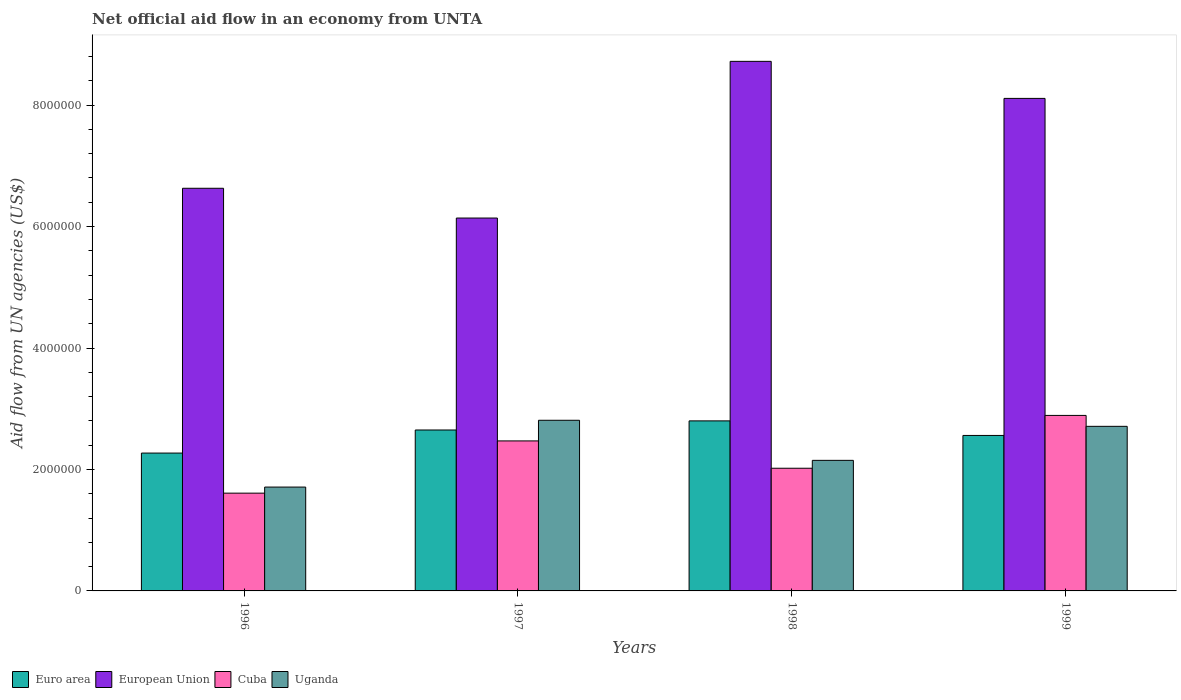How many groups of bars are there?
Make the answer very short. 4. Are the number of bars per tick equal to the number of legend labels?
Make the answer very short. Yes. How many bars are there on the 2nd tick from the left?
Your answer should be compact. 4. How many bars are there on the 2nd tick from the right?
Make the answer very short. 4. What is the net official aid flow in Euro area in 1996?
Ensure brevity in your answer.  2.27e+06. Across all years, what is the maximum net official aid flow in Cuba?
Your answer should be very brief. 2.89e+06. Across all years, what is the minimum net official aid flow in Cuba?
Offer a terse response. 1.61e+06. What is the total net official aid flow in Uganda in the graph?
Your answer should be compact. 9.38e+06. What is the difference between the net official aid flow in European Union in 1997 and that in 1998?
Your answer should be very brief. -2.58e+06. What is the difference between the net official aid flow in Cuba in 1998 and the net official aid flow in European Union in 1996?
Keep it short and to the point. -4.61e+06. What is the average net official aid flow in Uganda per year?
Keep it short and to the point. 2.34e+06. In the year 1996, what is the difference between the net official aid flow in Uganda and net official aid flow in Euro area?
Your answer should be compact. -5.60e+05. What is the ratio of the net official aid flow in Euro area in 1996 to that in 1998?
Provide a short and direct response. 0.81. Is the difference between the net official aid flow in Uganda in 1998 and 1999 greater than the difference between the net official aid flow in Euro area in 1998 and 1999?
Offer a very short reply. No. What is the difference between the highest and the second highest net official aid flow in Cuba?
Give a very brief answer. 4.20e+05. What is the difference between the highest and the lowest net official aid flow in European Union?
Offer a terse response. 2.58e+06. What does the 2nd bar from the left in 1997 represents?
Keep it short and to the point. European Union. What does the 1st bar from the right in 1999 represents?
Give a very brief answer. Uganda. What is the difference between two consecutive major ticks on the Y-axis?
Ensure brevity in your answer.  2.00e+06. Are the values on the major ticks of Y-axis written in scientific E-notation?
Your answer should be very brief. No. Does the graph contain grids?
Your response must be concise. No. How many legend labels are there?
Your answer should be very brief. 4. What is the title of the graph?
Keep it short and to the point. Net official aid flow in an economy from UNTA. Does "Chile" appear as one of the legend labels in the graph?
Your response must be concise. No. What is the label or title of the Y-axis?
Your response must be concise. Aid flow from UN agencies (US$). What is the Aid flow from UN agencies (US$) in Euro area in 1996?
Your answer should be compact. 2.27e+06. What is the Aid flow from UN agencies (US$) in European Union in 1996?
Provide a succinct answer. 6.63e+06. What is the Aid flow from UN agencies (US$) in Cuba in 1996?
Make the answer very short. 1.61e+06. What is the Aid flow from UN agencies (US$) in Uganda in 1996?
Ensure brevity in your answer.  1.71e+06. What is the Aid flow from UN agencies (US$) of Euro area in 1997?
Offer a terse response. 2.65e+06. What is the Aid flow from UN agencies (US$) in European Union in 1997?
Your answer should be compact. 6.14e+06. What is the Aid flow from UN agencies (US$) in Cuba in 1997?
Make the answer very short. 2.47e+06. What is the Aid flow from UN agencies (US$) in Uganda in 1997?
Your answer should be very brief. 2.81e+06. What is the Aid flow from UN agencies (US$) of Euro area in 1998?
Your answer should be very brief. 2.80e+06. What is the Aid flow from UN agencies (US$) of European Union in 1998?
Your answer should be very brief. 8.72e+06. What is the Aid flow from UN agencies (US$) in Cuba in 1998?
Your answer should be very brief. 2.02e+06. What is the Aid flow from UN agencies (US$) of Uganda in 1998?
Your answer should be very brief. 2.15e+06. What is the Aid flow from UN agencies (US$) of Euro area in 1999?
Your answer should be very brief. 2.56e+06. What is the Aid flow from UN agencies (US$) in European Union in 1999?
Keep it short and to the point. 8.11e+06. What is the Aid flow from UN agencies (US$) of Cuba in 1999?
Offer a very short reply. 2.89e+06. What is the Aid flow from UN agencies (US$) in Uganda in 1999?
Ensure brevity in your answer.  2.71e+06. Across all years, what is the maximum Aid flow from UN agencies (US$) in Euro area?
Your answer should be compact. 2.80e+06. Across all years, what is the maximum Aid flow from UN agencies (US$) in European Union?
Keep it short and to the point. 8.72e+06. Across all years, what is the maximum Aid flow from UN agencies (US$) in Cuba?
Make the answer very short. 2.89e+06. Across all years, what is the maximum Aid flow from UN agencies (US$) in Uganda?
Your response must be concise. 2.81e+06. Across all years, what is the minimum Aid flow from UN agencies (US$) of Euro area?
Provide a succinct answer. 2.27e+06. Across all years, what is the minimum Aid flow from UN agencies (US$) of European Union?
Make the answer very short. 6.14e+06. Across all years, what is the minimum Aid flow from UN agencies (US$) of Cuba?
Provide a short and direct response. 1.61e+06. Across all years, what is the minimum Aid flow from UN agencies (US$) of Uganda?
Make the answer very short. 1.71e+06. What is the total Aid flow from UN agencies (US$) in Euro area in the graph?
Offer a very short reply. 1.03e+07. What is the total Aid flow from UN agencies (US$) in European Union in the graph?
Provide a short and direct response. 2.96e+07. What is the total Aid flow from UN agencies (US$) in Cuba in the graph?
Give a very brief answer. 8.99e+06. What is the total Aid flow from UN agencies (US$) of Uganda in the graph?
Keep it short and to the point. 9.38e+06. What is the difference between the Aid flow from UN agencies (US$) in Euro area in 1996 and that in 1997?
Ensure brevity in your answer.  -3.80e+05. What is the difference between the Aid flow from UN agencies (US$) in European Union in 1996 and that in 1997?
Provide a short and direct response. 4.90e+05. What is the difference between the Aid flow from UN agencies (US$) of Cuba in 1996 and that in 1997?
Your answer should be very brief. -8.60e+05. What is the difference between the Aid flow from UN agencies (US$) in Uganda in 1996 and that in 1997?
Keep it short and to the point. -1.10e+06. What is the difference between the Aid flow from UN agencies (US$) of Euro area in 1996 and that in 1998?
Keep it short and to the point. -5.30e+05. What is the difference between the Aid flow from UN agencies (US$) in European Union in 1996 and that in 1998?
Provide a short and direct response. -2.09e+06. What is the difference between the Aid flow from UN agencies (US$) of Cuba in 1996 and that in 1998?
Your answer should be compact. -4.10e+05. What is the difference between the Aid flow from UN agencies (US$) in Uganda in 1996 and that in 1998?
Offer a terse response. -4.40e+05. What is the difference between the Aid flow from UN agencies (US$) of Euro area in 1996 and that in 1999?
Give a very brief answer. -2.90e+05. What is the difference between the Aid flow from UN agencies (US$) in European Union in 1996 and that in 1999?
Give a very brief answer. -1.48e+06. What is the difference between the Aid flow from UN agencies (US$) in Cuba in 1996 and that in 1999?
Offer a terse response. -1.28e+06. What is the difference between the Aid flow from UN agencies (US$) of Uganda in 1996 and that in 1999?
Offer a terse response. -1.00e+06. What is the difference between the Aid flow from UN agencies (US$) of European Union in 1997 and that in 1998?
Provide a short and direct response. -2.58e+06. What is the difference between the Aid flow from UN agencies (US$) in Cuba in 1997 and that in 1998?
Your answer should be very brief. 4.50e+05. What is the difference between the Aid flow from UN agencies (US$) of European Union in 1997 and that in 1999?
Provide a short and direct response. -1.97e+06. What is the difference between the Aid flow from UN agencies (US$) in Cuba in 1997 and that in 1999?
Offer a very short reply. -4.20e+05. What is the difference between the Aid flow from UN agencies (US$) in European Union in 1998 and that in 1999?
Give a very brief answer. 6.10e+05. What is the difference between the Aid flow from UN agencies (US$) in Cuba in 1998 and that in 1999?
Your response must be concise. -8.70e+05. What is the difference between the Aid flow from UN agencies (US$) in Uganda in 1998 and that in 1999?
Offer a very short reply. -5.60e+05. What is the difference between the Aid flow from UN agencies (US$) of Euro area in 1996 and the Aid flow from UN agencies (US$) of European Union in 1997?
Keep it short and to the point. -3.87e+06. What is the difference between the Aid flow from UN agencies (US$) in Euro area in 1996 and the Aid flow from UN agencies (US$) in Cuba in 1997?
Keep it short and to the point. -2.00e+05. What is the difference between the Aid flow from UN agencies (US$) in Euro area in 1996 and the Aid flow from UN agencies (US$) in Uganda in 1997?
Give a very brief answer. -5.40e+05. What is the difference between the Aid flow from UN agencies (US$) in European Union in 1996 and the Aid flow from UN agencies (US$) in Cuba in 1997?
Offer a very short reply. 4.16e+06. What is the difference between the Aid flow from UN agencies (US$) of European Union in 1996 and the Aid flow from UN agencies (US$) of Uganda in 1997?
Ensure brevity in your answer.  3.82e+06. What is the difference between the Aid flow from UN agencies (US$) of Cuba in 1996 and the Aid flow from UN agencies (US$) of Uganda in 1997?
Your answer should be very brief. -1.20e+06. What is the difference between the Aid flow from UN agencies (US$) in Euro area in 1996 and the Aid flow from UN agencies (US$) in European Union in 1998?
Give a very brief answer. -6.45e+06. What is the difference between the Aid flow from UN agencies (US$) in Euro area in 1996 and the Aid flow from UN agencies (US$) in Uganda in 1998?
Keep it short and to the point. 1.20e+05. What is the difference between the Aid flow from UN agencies (US$) of European Union in 1996 and the Aid flow from UN agencies (US$) of Cuba in 1998?
Keep it short and to the point. 4.61e+06. What is the difference between the Aid flow from UN agencies (US$) of European Union in 1996 and the Aid flow from UN agencies (US$) of Uganda in 1998?
Give a very brief answer. 4.48e+06. What is the difference between the Aid flow from UN agencies (US$) in Cuba in 1996 and the Aid flow from UN agencies (US$) in Uganda in 1998?
Make the answer very short. -5.40e+05. What is the difference between the Aid flow from UN agencies (US$) in Euro area in 1996 and the Aid flow from UN agencies (US$) in European Union in 1999?
Make the answer very short. -5.84e+06. What is the difference between the Aid flow from UN agencies (US$) in Euro area in 1996 and the Aid flow from UN agencies (US$) in Cuba in 1999?
Ensure brevity in your answer.  -6.20e+05. What is the difference between the Aid flow from UN agencies (US$) of Euro area in 1996 and the Aid flow from UN agencies (US$) of Uganda in 1999?
Your answer should be very brief. -4.40e+05. What is the difference between the Aid flow from UN agencies (US$) in European Union in 1996 and the Aid flow from UN agencies (US$) in Cuba in 1999?
Keep it short and to the point. 3.74e+06. What is the difference between the Aid flow from UN agencies (US$) in European Union in 1996 and the Aid flow from UN agencies (US$) in Uganda in 1999?
Provide a short and direct response. 3.92e+06. What is the difference between the Aid flow from UN agencies (US$) in Cuba in 1996 and the Aid flow from UN agencies (US$) in Uganda in 1999?
Make the answer very short. -1.10e+06. What is the difference between the Aid flow from UN agencies (US$) in Euro area in 1997 and the Aid flow from UN agencies (US$) in European Union in 1998?
Your response must be concise. -6.07e+06. What is the difference between the Aid flow from UN agencies (US$) of Euro area in 1997 and the Aid flow from UN agencies (US$) of Cuba in 1998?
Your answer should be very brief. 6.30e+05. What is the difference between the Aid flow from UN agencies (US$) of Euro area in 1997 and the Aid flow from UN agencies (US$) of Uganda in 1998?
Provide a short and direct response. 5.00e+05. What is the difference between the Aid flow from UN agencies (US$) in European Union in 1997 and the Aid flow from UN agencies (US$) in Cuba in 1998?
Make the answer very short. 4.12e+06. What is the difference between the Aid flow from UN agencies (US$) of European Union in 1997 and the Aid flow from UN agencies (US$) of Uganda in 1998?
Your response must be concise. 3.99e+06. What is the difference between the Aid flow from UN agencies (US$) of Euro area in 1997 and the Aid flow from UN agencies (US$) of European Union in 1999?
Offer a very short reply. -5.46e+06. What is the difference between the Aid flow from UN agencies (US$) in Euro area in 1997 and the Aid flow from UN agencies (US$) in Uganda in 1999?
Make the answer very short. -6.00e+04. What is the difference between the Aid flow from UN agencies (US$) of European Union in 1997 and the Aid flow from UN agencies (US$) of Cuba in 1999?
Offer a very short reply. 3.25e+06. What is the difference between the Aid flow from UN agencies (US$) in European Union in 1997 and the Aid flow from UN agencies (US$) in Uganda in 1999?
Keep it short and to the point. 3.43e+06. What is the difference between the Aid flow from UN agencies (US$) of Euro area in 1998 and the Aid flow from UN agencies (US$) of European Union in 1999?
Offer a terse response. -5.31e+06. What is the difference between the Aid flow from UN agencies (US$) in Euro area in 1998 and the Aid flow from UN agencies (US$) in Cuba in 1999?
Your answer should be compact. -9.00e+04. What is the difference between the Aid flow from UN agencies (US$) in Euro area in 1998 and the Aid flow from UN agencies (US$) in Uganda in 1999?
Keep it short and to the point. 9.00e+04. What is the difference between the Aid flow from UN agencies (US$) in European Union in 1998 and the Aid flow from UN agencies (US$) in Cuba in 1999?
Your response must be concise. 5.83e+06. What is the difference between the Aid flow from UN agencies (US$) of European Union in 1998 and the Aid flow from UN agencies (US$) of Uganda in 1999?
Offer a very short reply. 6.01e+06. What is the difference between the Aid flow from UN agencies (US$) of Cuba in 1998 and the Aid flow from UN agencies (US$) of Uganda in 1999?
Provide a short and direct response. -6.90e+05. What is the average Aid flow from UN agencies (US$) in Euro area per year?
Ensure brevity in your answer.  2.57e+06. What is the average Aid flow from UN agencies (US$) of European Union per year?
Your response must be concise. 7.40e+06. What is the average Aid flow from UN agencies (US$) in Cuba per year?
Keep it short and to the point. 2.25e+06. What is the average Aid flow from UN agencies (US$) in Uganda per year?
Ensure brevity in your answer.  2.34e+06. In the year 1996, what is the difference between the Aid flow from UN agencies (US$) in Euro area and Aid flow from UN agencies (US$) in European Union?
Your answer should be very brief. -4.36e+06. In the year 1996, what is the difference between the Aid flow from UN agencies (US$) in Euro area and Aid flow from UN agencies (US$) in Cuba?
Give a very brief answer. 6.60e+05. In the year 1996, what is the difference between the Aid flow from UN agencies (US$) of Euro area and Aid flow from UN agencies (US$) of Uganda?
Ensure brevity in your answer.  5.60e+05. In the year 1996, what is the difference between the Aid flow from UN agencies (US$) of European Union and Aid flow from UN agencies (US$) of Cuba?
Provide a short and direct response. 5.02e+06. In the year 1996, what is the difference between the Aid flow from UN agencies (US$) of European Union and Aid flow from UN agencies (US$) of Uganda?
Your answer should be compact. 4.92e+06. In the year 1997, what is the difference between the Aid flow from UN agencies (US$) in Euro area and Aid flow from UN agencies (US$) in European Union?
Your answer should be compact. -3.49e+06. In the year 1997, what is the difference between the Aid flow from UN agencies (US$) of European Union and Aid flow from UN agencies (US$) of Cuba?
Give a very brief answer. 3.67e+06. In the year 1997, what is the difference between the Aid flow from UN agencies (US$) of European Union and Aid flow from UN agencies (US$) of Uganda?
Your answer should be very brief. 3.33e+06. In the year 1998, what is the difference between the Aid flow from UN agencies (US$) of Euro area and Aid flow from UN agencies (US$) of European Union?
Your answer should be compact. -5.92e+06. In the year 1998, what is the difference between the Aid flow from UN agencies (US$) in Euro area and Aid flow from UN agencies (US$) in Cuba?
Keep it short and to the point. 7.80e+05. In the year 1998, what is the difference between the Aid flow from UN agencies (US$) of Euro area and Aid flow from UN agencies (US$) of Uganda?
Give a very brief answer. 6.50e+05. In the year 1998, what is the difference between the Aid flow from UN agencies (US$) of European Union and Aid flow from UN agencies (US$) of Cuba?
Your response must be concise. 6.70e+06. In the year 1998, what is the difference between the Aid flow from UN agencies (US$) in European Union and Aid flow from UN agencies (US$) in Uganda?
Your answer should be very brief. 6.57e+06. In the year 1998, what is the difference between the Aid flow from UN agencies (US$) in Cuba and Aid flow from UN agencies (US$) in Uganda?
Make the answer very short. -1.30e+05. In the year 1999, what is the difference between the Aid flow from UN agencies (US$) of Euro area and Aid flow from UN agencies (US$) of European Union?
Ensure brevity in your answer.  -5.55e+06. In the year 1999, what is the difference between the Aid flow from UN agencies (US$) in Euro area and Aid flow from UN agencies (US$) in Cuba?
Ensure brevity in your answer.  -3.30e+05. In the year 1999, what is the difference between the Aid flow from UN agencies (US$) of Euro area and Aid flow from UN agencies (US$) of Uganda?
Your answer should be compact. -1.50e+05. In the year 1999, what is the difference between the Aid flow from UN agencies (US$) in European Union and Aid flow from UN agencies (US$) in Cuba?
Provide a succinct answer. 5.22e+06. In the year 1999, what is the difference between the Aid flow from UN agencies (US$) in European Union and Aid flow from UN agencies (US$) in Uganda?
Make the answer very short. 5.40e+06. In the year 1999, what is the difference between the Aid flow from UN agencies (US$) of Cuba and Aid flow from UN agencies (US$) of Uganda?
Offer a terse response. 1.80e+05. What is the ratio of the Aid flow from UN agencies (US$) of Euro area in 1996 to that in 1997?
Your answer should be very brief. 0.86. What is the ratio of the Aid flow from UN agencies (US$) in European Union in 1996 to that in 1997?
Offer a terse response. 1.08. What is the ratio of the Aid flow from UN agencies (US$) of Cuba in 1996 to that in 1997?
Make the answer very short. 0.65. What is the ratio of the Aid flow from UN agencies (US$) of Uganda in 1996 to that in 1997?
Provide a succinct answer. 0.61. What is the ratio of the Aid flow from UN agencies (US$) in Euro area in 1996 to that in 1998?
Provide a short and direct response. 0.81. What is the ratio of the Aid flow from UN agencies (US$) of European Union in 1996 to that in 1998?
Provide a succinct answer. 0.76. What is the ratio of the Aid flow from UN agencies (US$) of Cuba in 1996 to that in 1998?
Your answer should be very brief. 0.8. What is the ratio of the Aid flow from UN agencies (US$) in Uganda in 1996 to that in 1998?
Your response must be concise. 0.8. What is the ratio of the Aid flow from UN agencies (US$) of Euro area in 1996 to that in 1999?
Provide a succinct answer. 0.89. What is the ratio of the Aid flow from UN agencies (US$) in European Union in 1996 to that in 1999?
Provide a short and direct response. 0.82. What is the ratio of the Aid flow from UN agencies (US$) in Cuba in 1996 to that in 1999?
Your answer should be very brief. 0.56. What is the ratio of the Aid flow from UN agencies (US$) in Uganda in 1996 to that in 1999?
Your response must be concise. 0.63. What is the ratio of the Aid flow from UN agencies (US$) of Euro area in 1997 to that in 1998?
Offer a very short reply. 0.95. What is the ratio of the Aid flow from UN agencies (US$) in European Union in 1997 to that in 1998?
Give a very brief answer. 0.7. What is the ratio of the Aid flow from UN agencies (US$) of Cuba in 1997 to that in 1998?
Offer a very short reply. 1.22. What is the ratio of the Aid flow from UN agencies (US$) of Uganda in 1997 to that in 1998?
Offer a terse response. 1.31. What is the ratio of the Aid flow from UN agencies (US$) of Euro area in 1997 to that in 1999?
Provide a succinct answer. 1.04. What is the ratio of the Aid flow from UN agencies (US$) in European Union in 1997 to that in 1999?
Give a very brief answer. 0.76. What is the ratio of the Aid flow from UN agencies (US$) of Cuba in 1997 to that in 1999?
Your response must be concise. 0.85. What is the ratio of the Aid flow from UN agencies (US$) in Uganda in 1997 to that in 1999?
Your response must be concise. 1.04. What is the ratio of the Aid flow from UN agencies (US$) in Euro area in 1998 to that in 1999?
Offer a very short reply. 1.09. What is the ratio of the Aid flow from UN agencies (US$) of European Union in 1998 to that in 1999?
Make the answer very short. 1.08. What is the ratio of the Aid flow from UN agencies (US$) of Cuba in 1998 to that in 1999?
Provide a succinct answer. 0.7. What is the ratio of the Aid flow from UN agencies (US$) of Uganda in 1998 to that in 1999?
Offer a very short reply. 0.79. What is the difference between the highest and the second highest Aid flow from UN agencies (US$) of European Union?
Provide a succinct answer. 6.10e+05. What is the difference between the highest and the lowest Aid flow from UN agencies (US$) of Euro area?
Offer a very short reply. 5.30e+05. What is the difference between the highest and the lowest Aid flow from UN agencies (US$) in European Union?
Your answer should be compact. 2.58e+06. What is the difference between the highest and the lowest Aid flow from UN agencies (US$) of Cuba?
Keep it short and to the point. 1.28e+06. What is the difference between the highest and the lowest Aid flow from UN agencies (US$) of Uganda?
Give a very brief answer. 1.10e+06. 